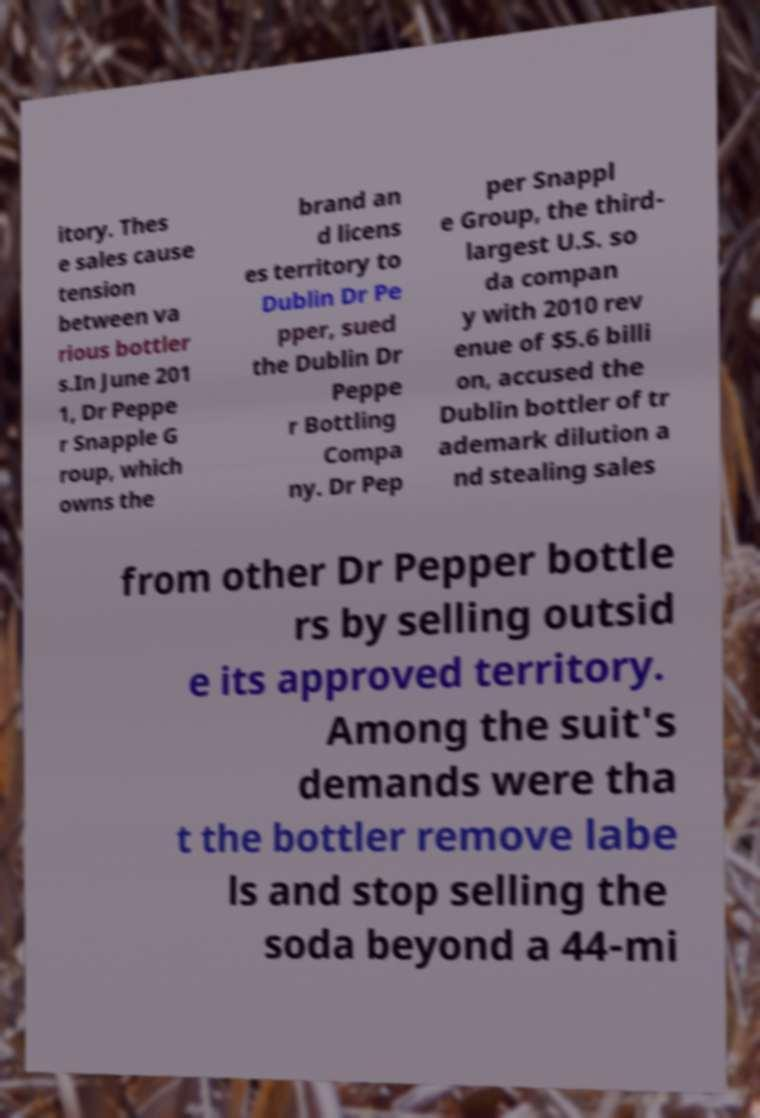I need the written content from this picture converted into text. Can you do that? itory. Thes e sales cause tension between va rious bottler s.In June 201 1, Dr Peppe r Snapple G roup, which owns the brand an d licens es territory to Dublin Dr Pe pper, sued the Dublin Dr Peppe r Bottling Compa ny. Dr Pep per Snappl e Group, the third- largest U.S. so da compan y with 2010 rev enue of $5.6 billi on, accused the Dublin bottler of tr ademark dilution a nd stealing sales from other Dr Pepper bottle rs by selling outsid e its approved territory. Among the suit's demands were tha t the bottler remove labe ls and stop selling the soda beyond a 44-mi 